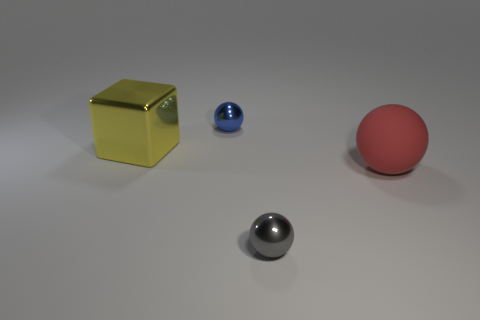Add 3 large matte balls. How many objects exist? 7 Subtract all balls. How many objects are left? 1 Add 1 big yellow things. How many big yellow things are left? 2 Add 3 yellow things. How many yellow things exist? 4 Subtract 0 gray cubes. How many objects are left? 4 Subtract all small red rubber balls. Subtract all yellow metallic objects. How many objects are left? 3 